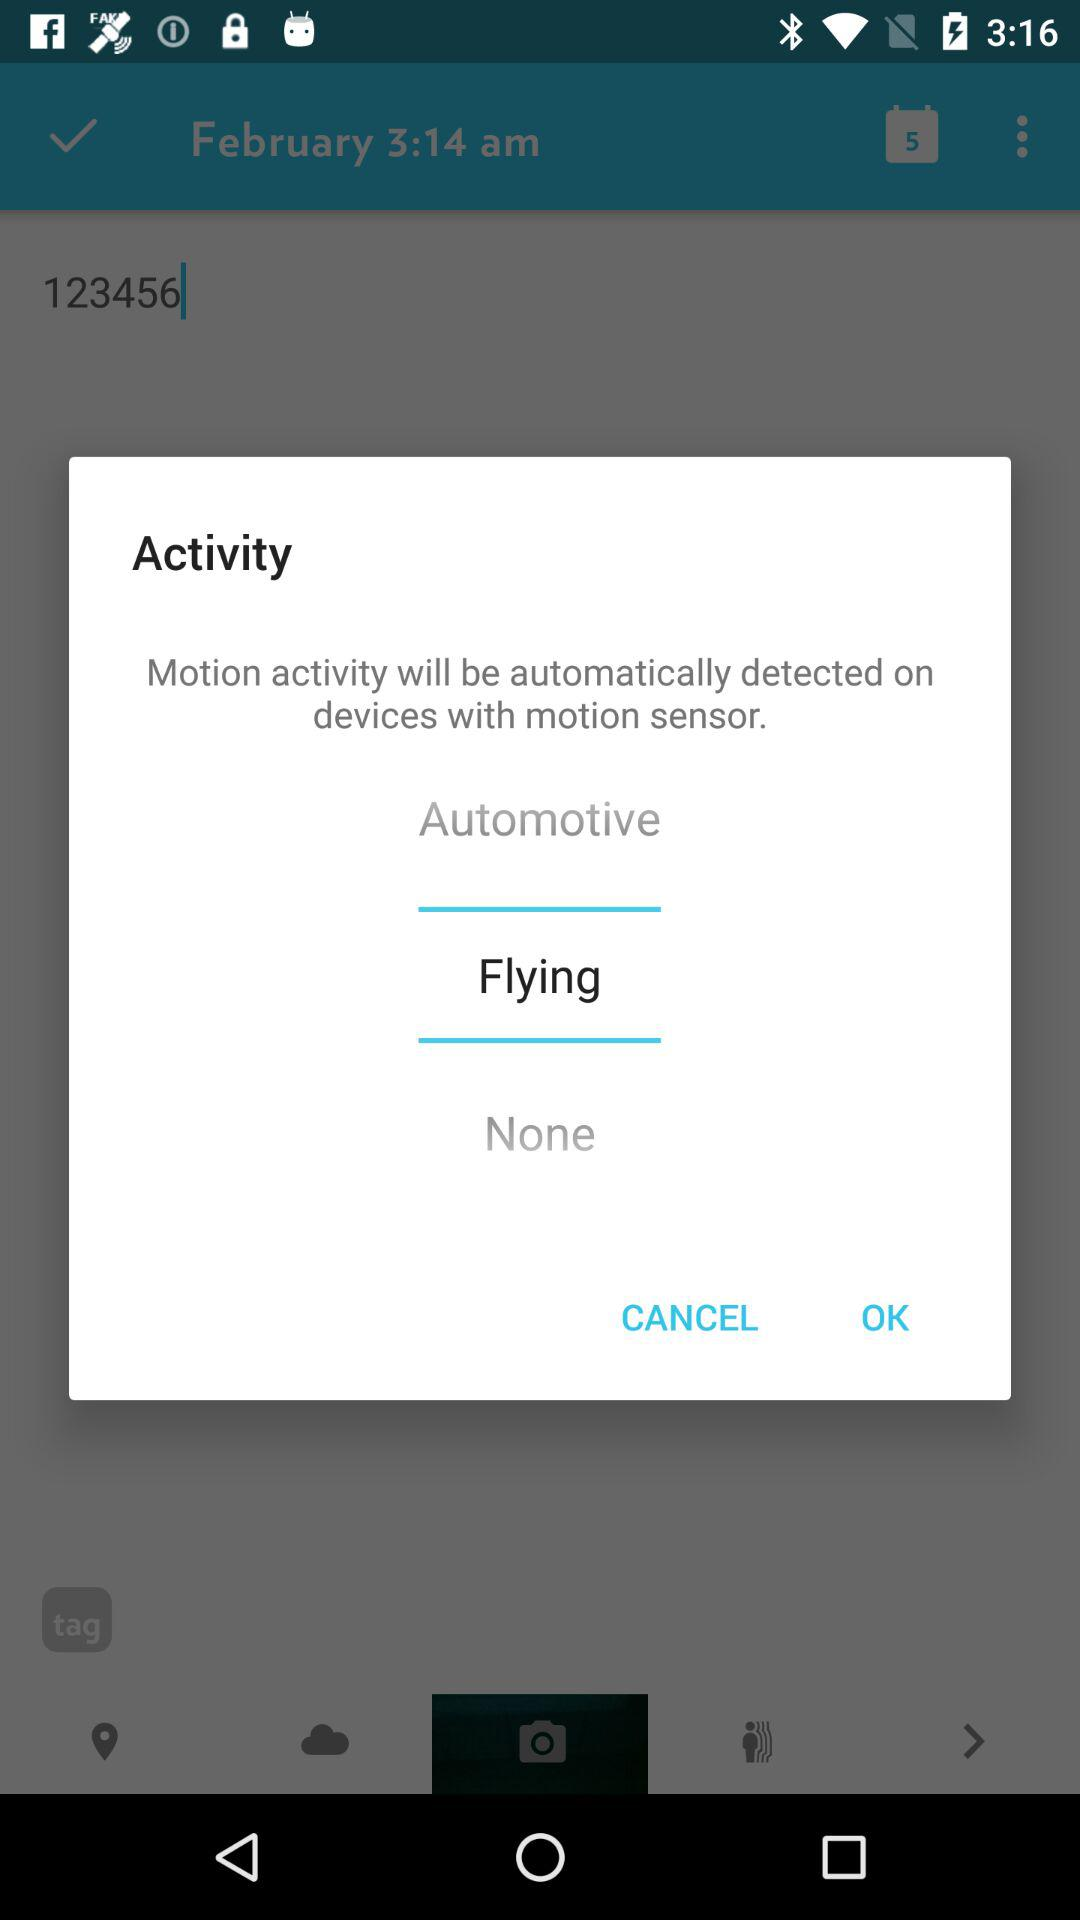What is the selected activity? The selected activity is flying. 